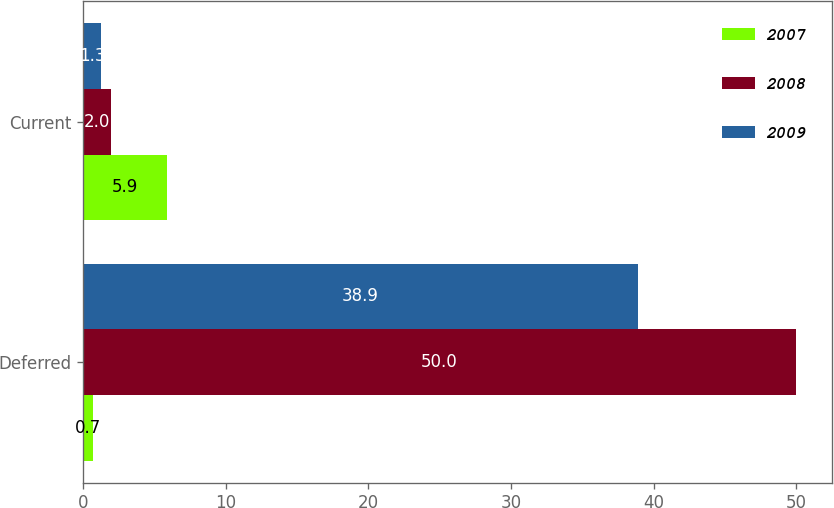Convert chart to OTSL. <chart><loc_0><loc_0><loc_500><loc_500><stacked_bar_chart><ecel><fcel>Deferred<fcel>Current<nl><fcel>2007<fcel>0.7<fcel>5.9<nl><fcel>2008<fcel>50<fcel>2<nl><fcel>2009<fcel>38.9<fcel>1.3<nl></chart> 